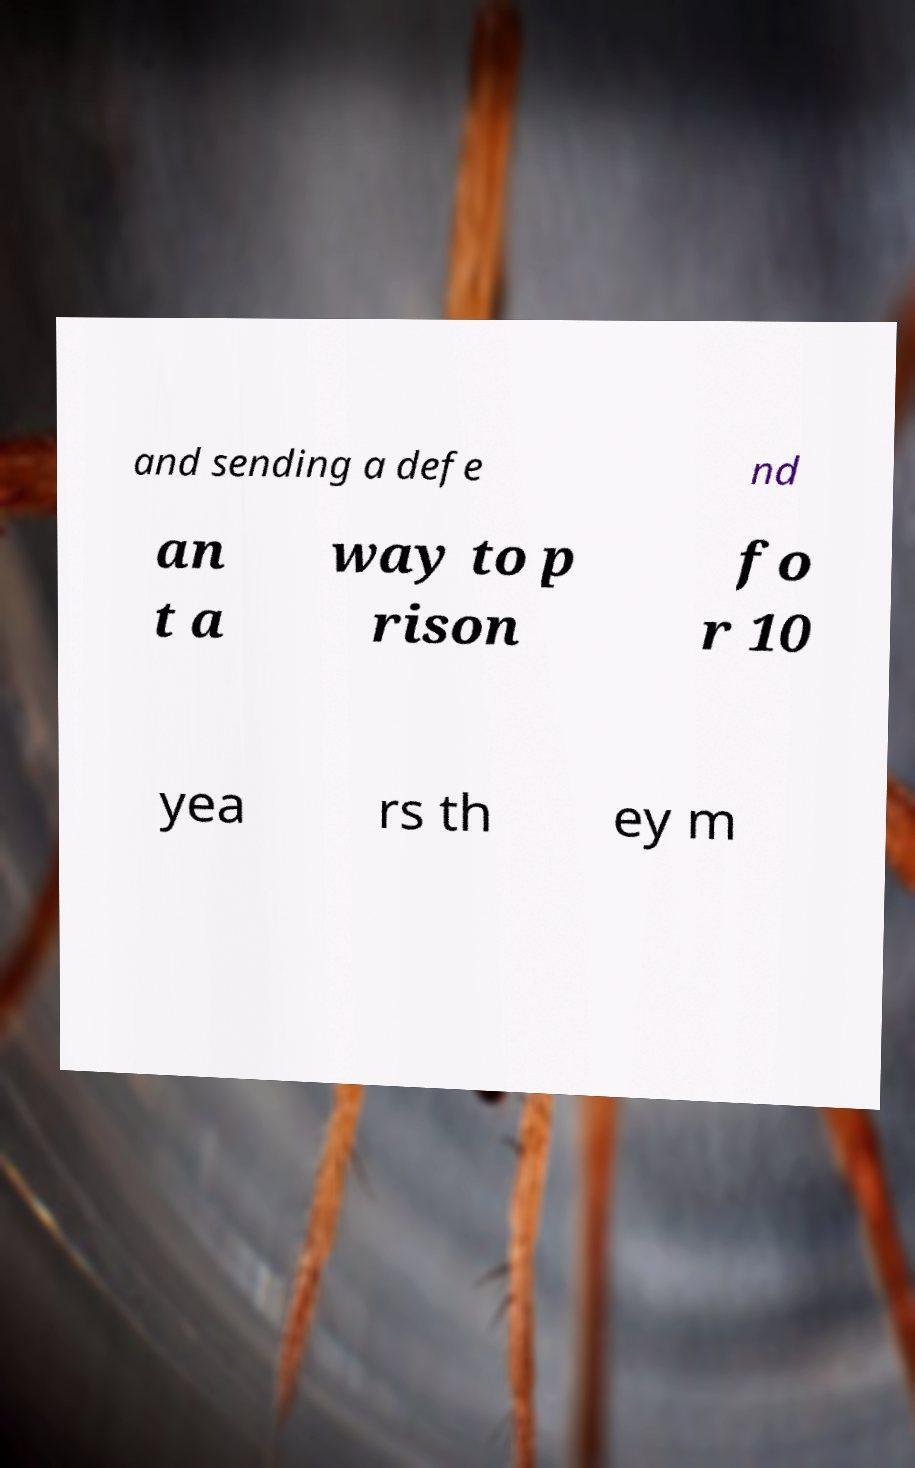I need the written content from this picture converted into text. Can you do that? and sending a defe nd an t a way to p rison fo r 10 yea rs th ey m 